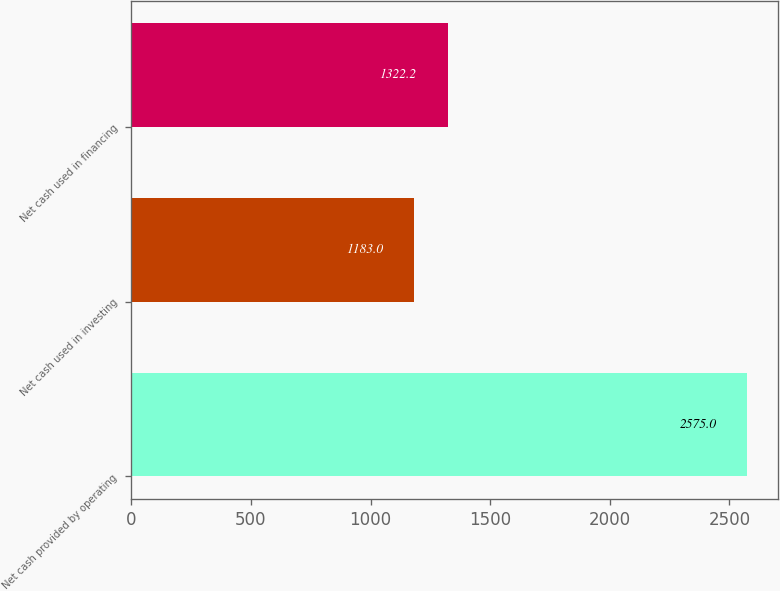Convert chart to OTSL. <chart><loc_0><loc_0><loc_500><loc_500><bar_chart><fcel>Net cash provided by operating<fcel>Net cash used in investing<fcel>Net cash used in financing<nl><fcel>2575<fcel>1183<fcel>1322.2<nl></chart> 